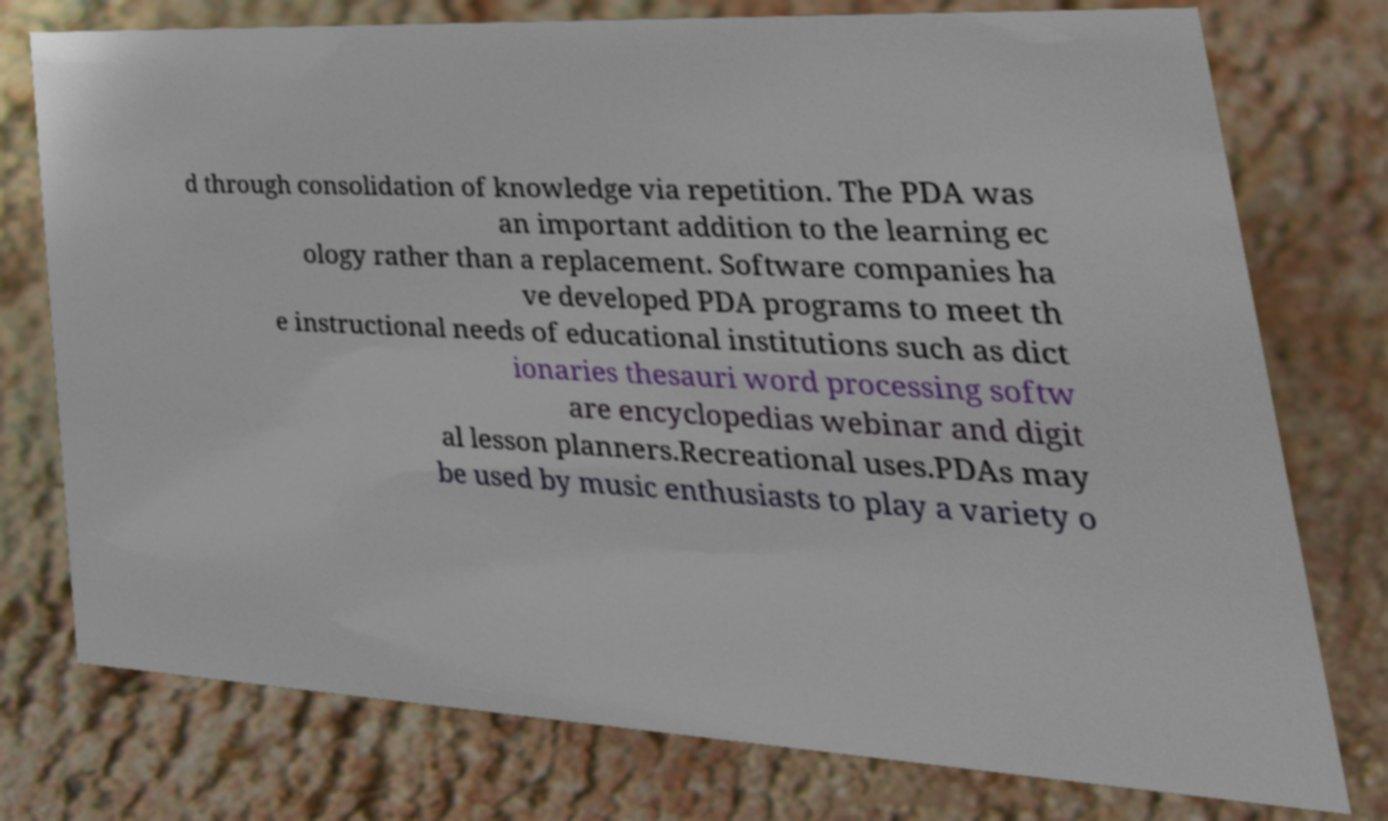I need the written content from this picture converted into text. Can you do that? d through consolidation of knowledge via repetition. The PDA was an important addition to the learning ec ology rather than a replacement. Software companies ha ve developed PDA programs to meet th e instructional needs of educational institutions such as dict ionaries thesauri word processing softw are encyclopedias webinar and digit al lesson planners.Recreational uses.PDAs may be used by music enthusiasts to play a variety o 